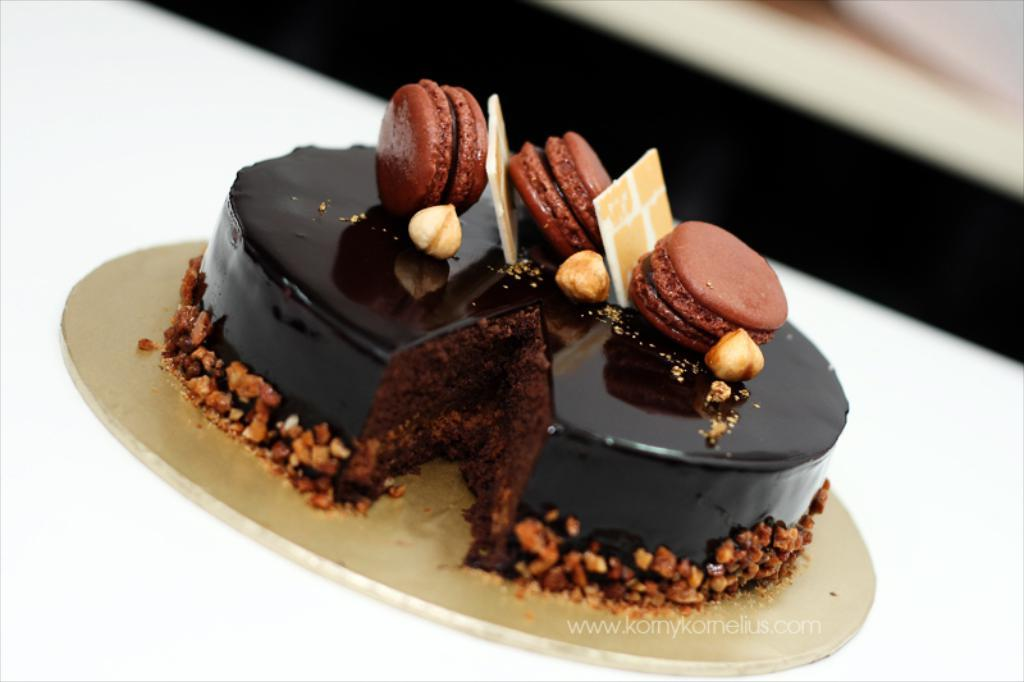What is the main food item in the image? There is a cake in the image. What is the color of the cake? The cake is black in color. What other food items can be seen in the image? There are biscuits and wafers in the image. What type of toppings or decorations are present around the cake? Dry fruits are present around the cake. How does the carriage fit into the image? There is no carriage present in the image. What act is being performed by the cake in the image? The cake is not performing any act; it is a stationary food item. 